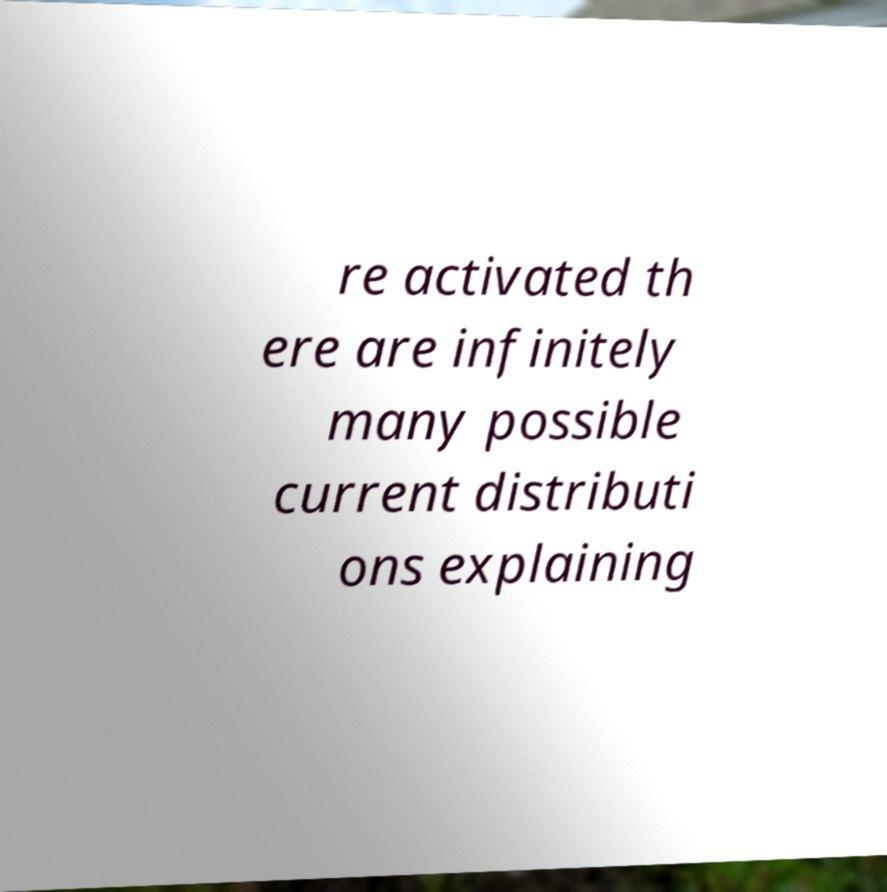Please read and relay the text visible in this image. What does it say? re activated th ere are infinitely many possible current distributi ons explaining 